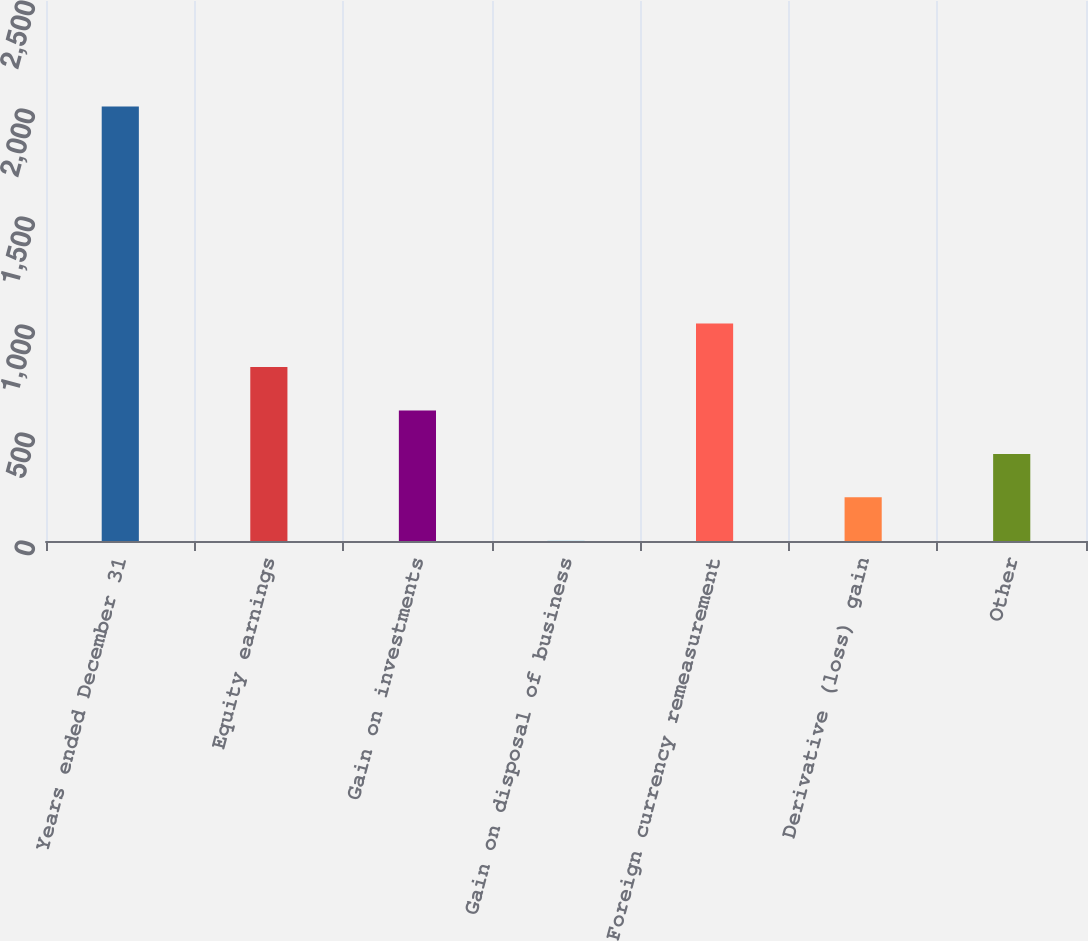<chart> <loc_0><loc_0><loc_500><loc_500><bar_chart><fcel>Years ended December 31<fcel>Equity earnings<fcel>Gain on investments<fcel>Gain on disposal of business<fcel>Foreign currency remeasurement<fcel>Derivative (loss) gain<fcel>Other<nl><fcel>2012<fcel>805.4<fcel>604.3<fcel>1<fcel>1006.5<fcel>202.1<fcel>403.2<nl></chart> 